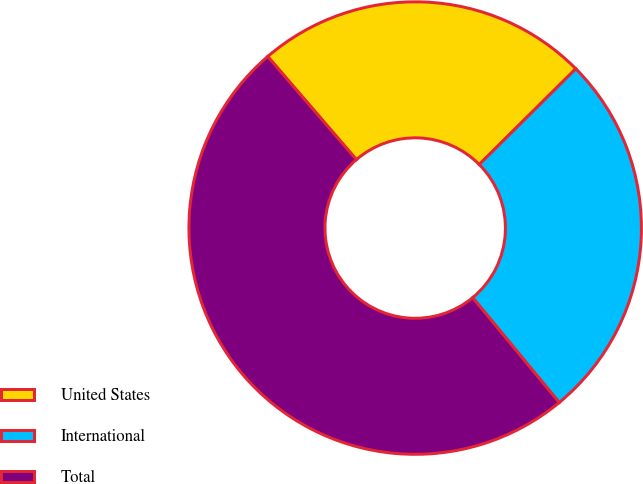Convert chart to OTSL. <chart><loc_0><loc_0><loc_500><loc_500><pie_chart><fcel>United States<fcel>International<fcel>Total<nl><fcel>23.87%<fcel>26.45%<fcel>49.68%<nl></chart> 